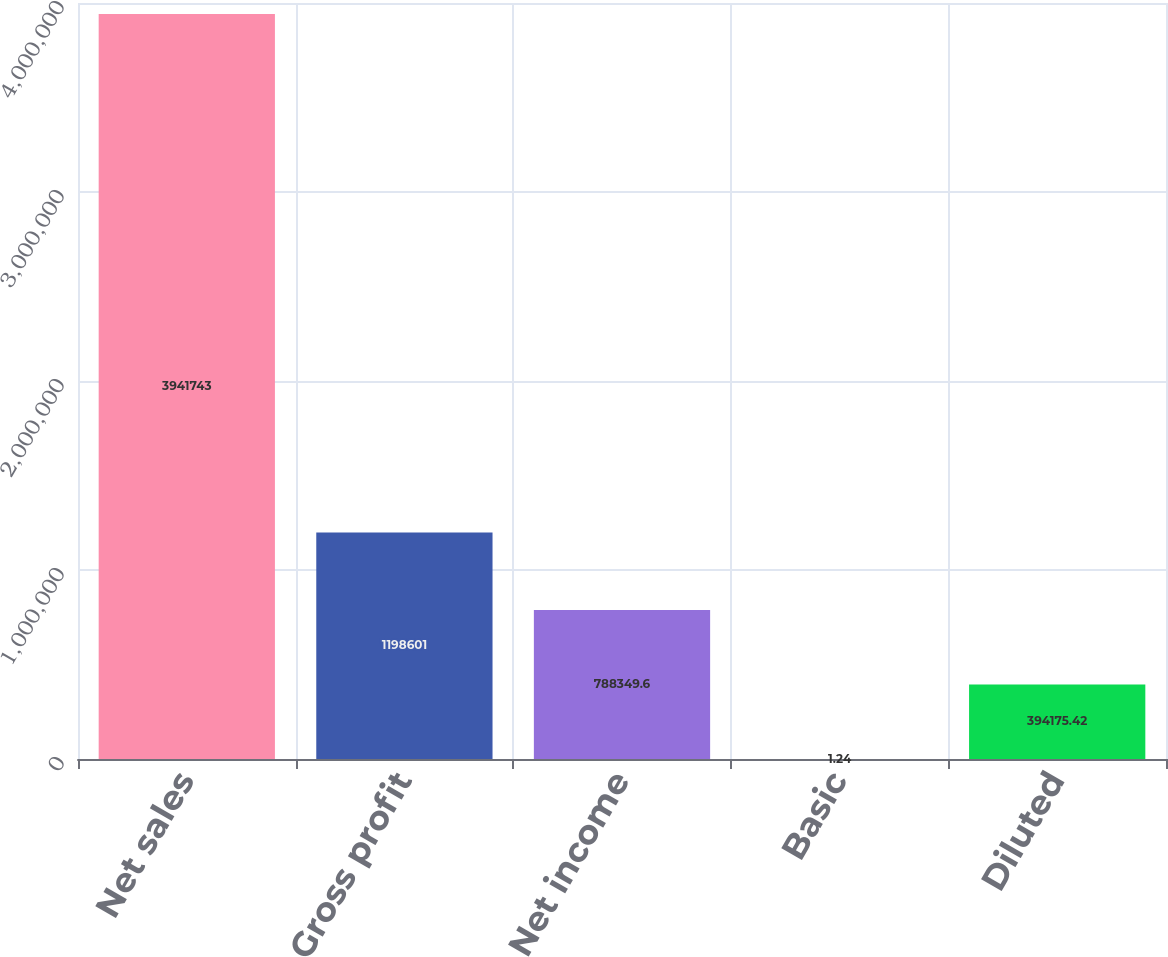Convert chart to OTSL. <chart><loc_0><loc_0><loc_500><loc_500><bar_chart><fcel>Net sales<fcel>Gross profit<fcel>Net income<fcel>Basic<fcel>Diluted<nl><fcel>3.94174e+06<fcel>1.1986e+06<fcel>788350<fcel>1.24<fcel>394175<nl></chart> 